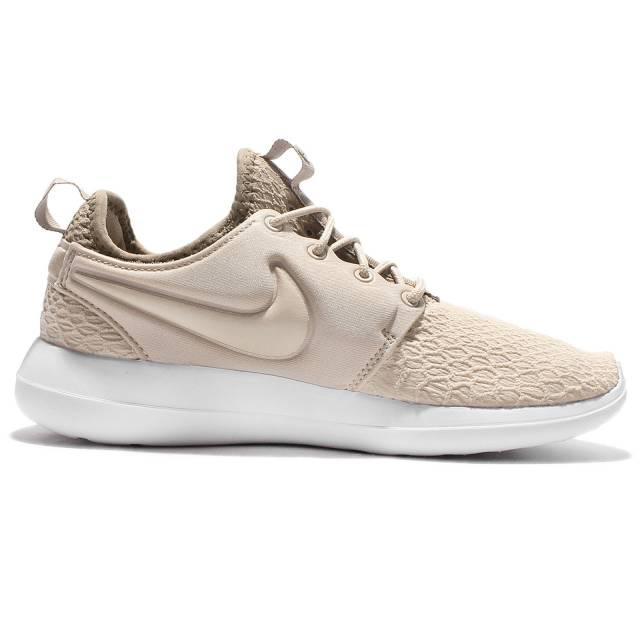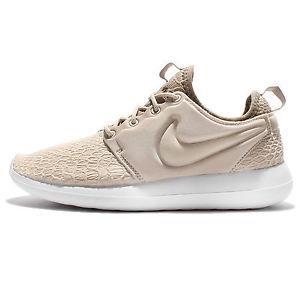The first image is the image on the left, the second image is the image on the right. Analyze the images presented: Is the assertion "The two shoes in the images are facing in opposite directions." valid? Answer yes or no. Yes. 